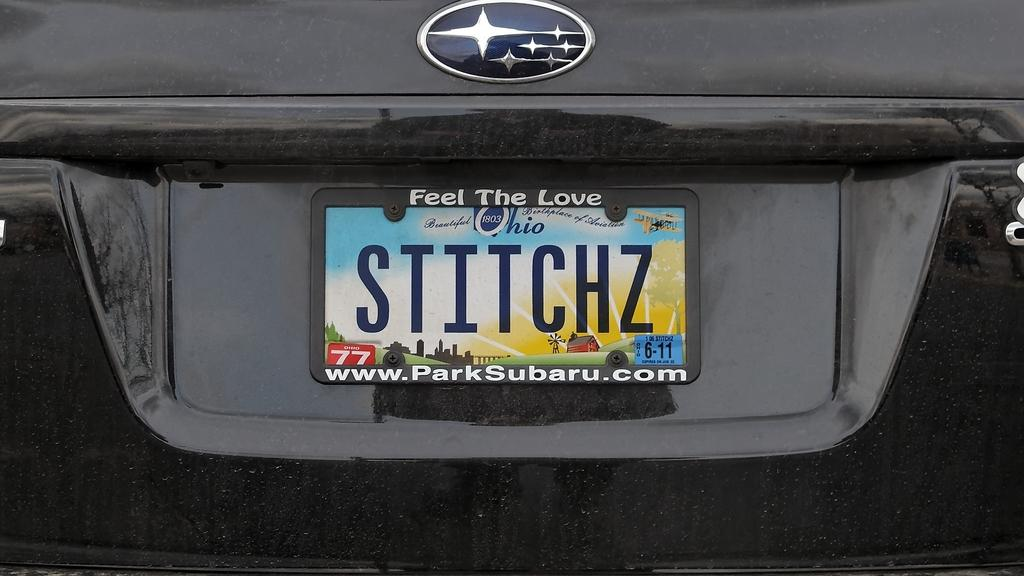<image>
Share a concise interpretation of the image provided. A feel the love license plate frame is around STTTCHZ. 